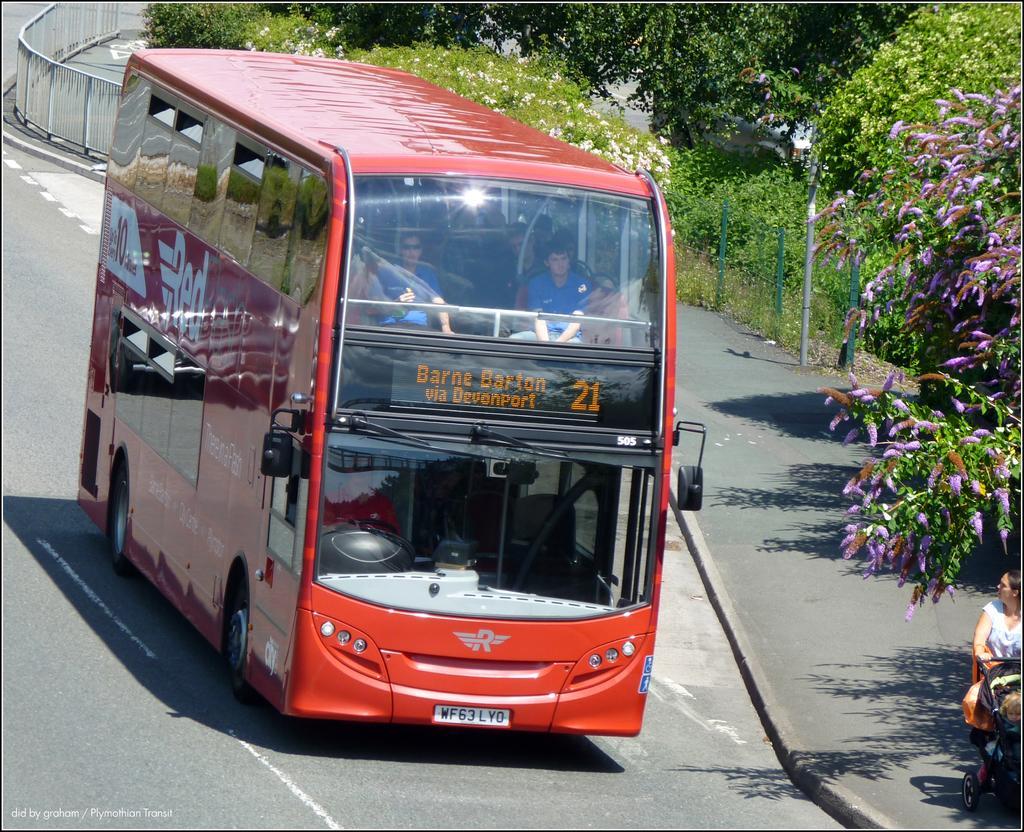Could you give a brief overview of what you see in this image? In this image we can see a bus on the road. We can also see some people sitting inside it. We can also see a fence, poles, some plants with flowers and some trees. At the bottom right we can see a person standing holding a baby carrier. 